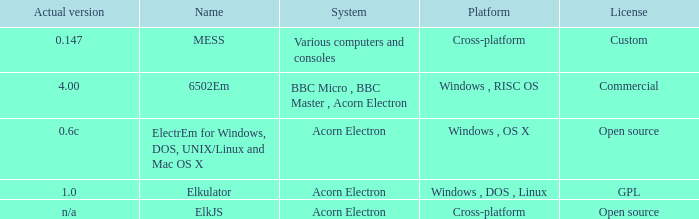What is the name of the platform used for various computers and consoles? Cross-platform. 